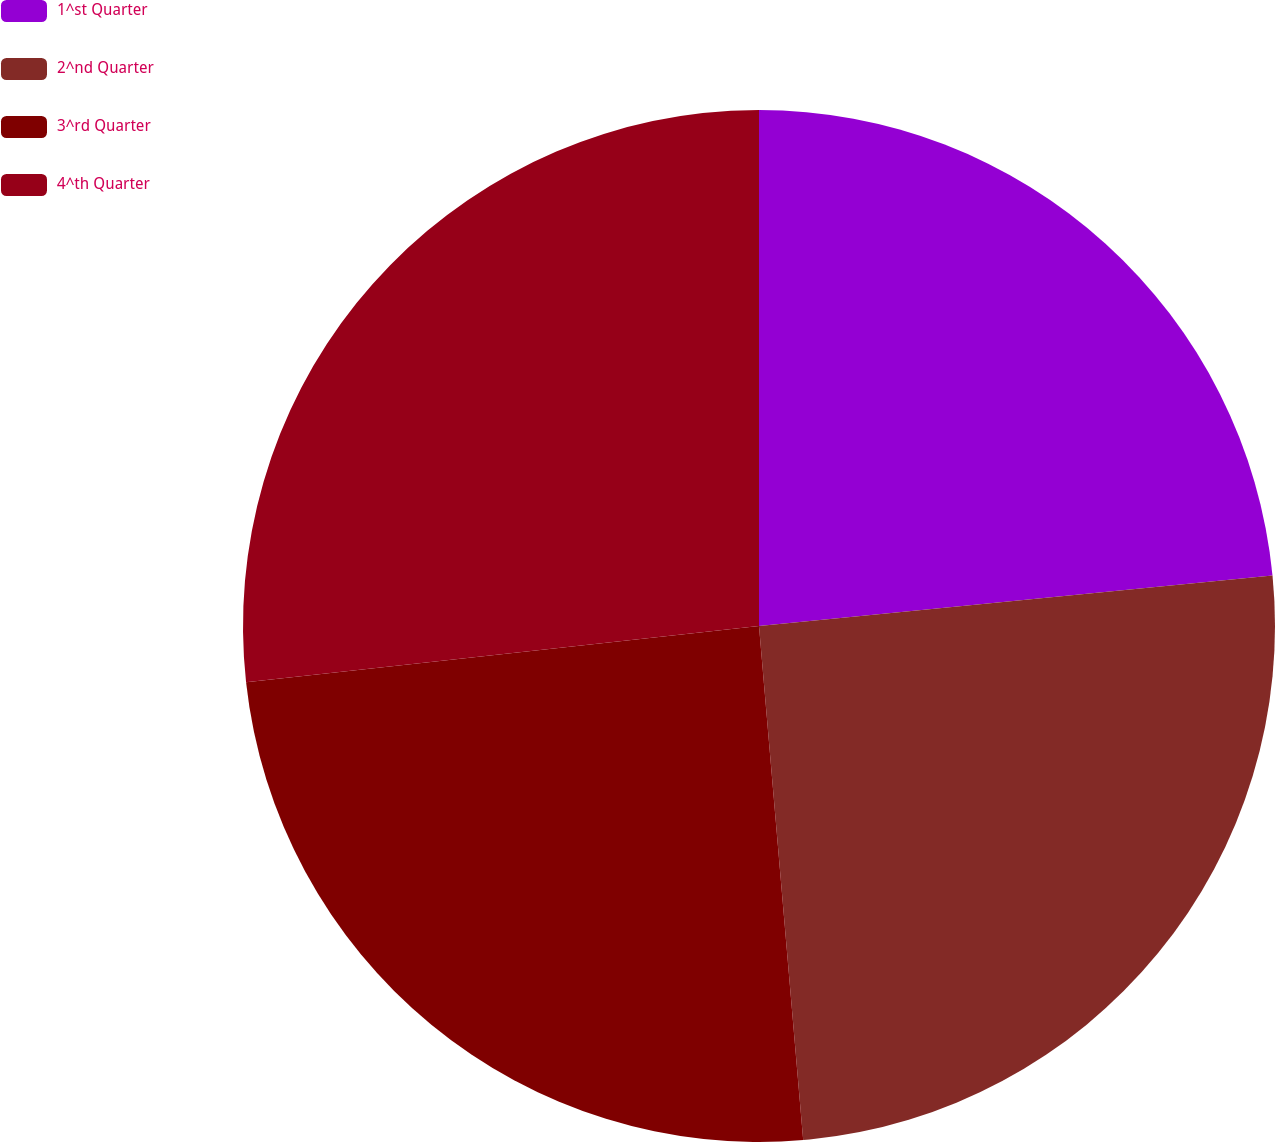Convert chart. <chart><loc_0><loc_0><loc_500><loc_500><pie_chart><fcel>1^st Quarter<fcel>2^nd Quarter<fcel>3^rd Quarter<fcel>4^th Quarter<nl><fcel>23.44%<fcel>25.2%<fcel>24.63%<fcel>26.74%<nl></chart> 